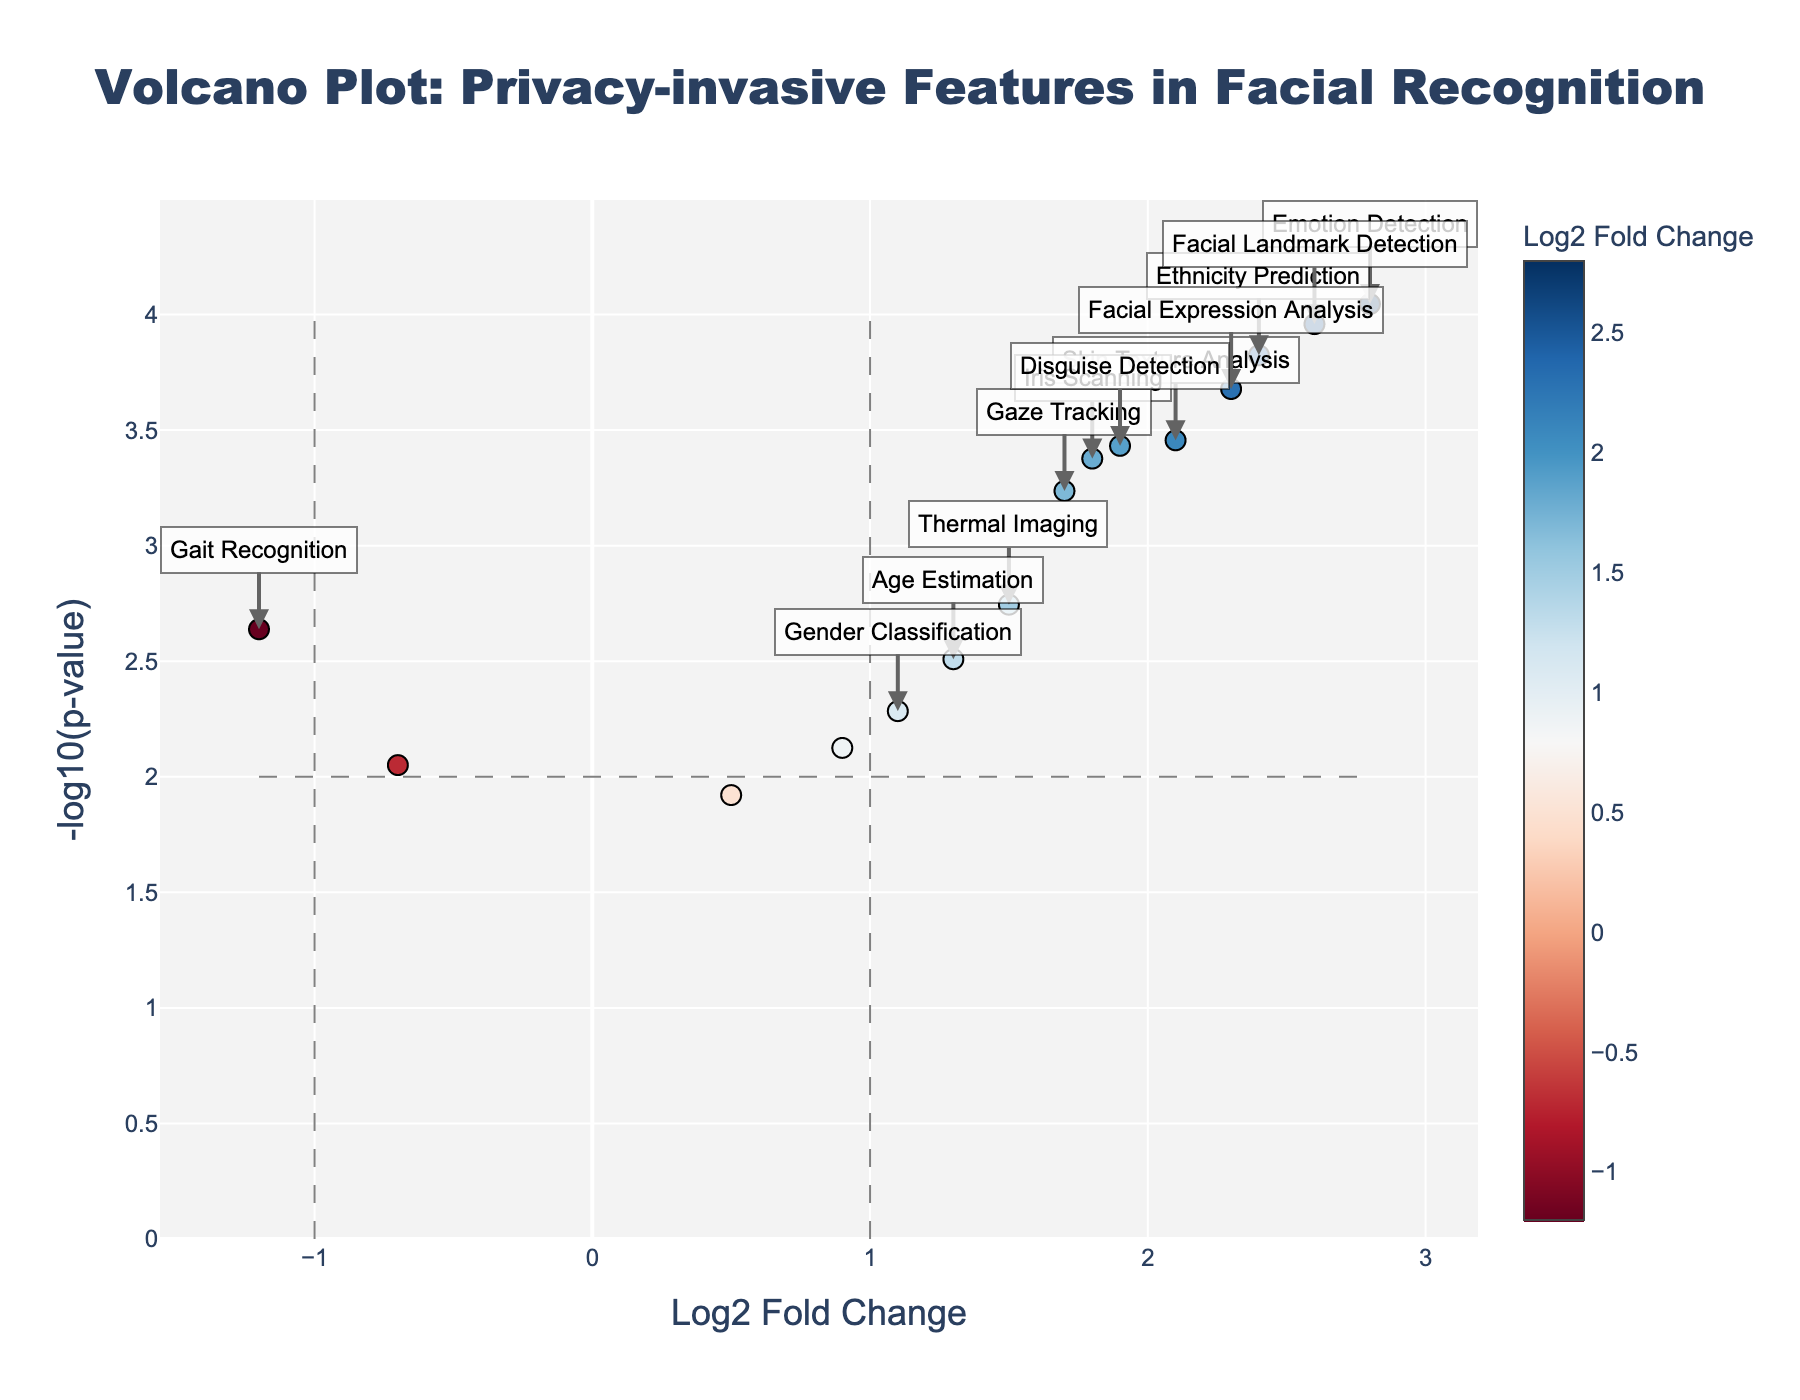How many features are plotted in the Volcano Plot? Count each data point representing a feature in the plot. There are 15 points, each corresponding to a unique feature.
Answer: 15 Which feature shows the highest fold change in privacy-invasive methods? Look for the data point farthest to the right on the X-axis (log2 Fold Change). "Emotion Detection" has the highest log2 fold change at 2.8.
Answer: Emotion Detection What is the significance threshold for the p-value indicated by the horizontal dashed line? Identify the -log10(p-value) for the horizontal line. The p-value threshold is 0.01, which corresponds to -log10(0.01) = 2.
Answer: 2 What feature is the least significant according to the plot, and what are its log2 fold change and p-value? Find the feature with the smallest -log10(p-value). "Tattoo Recognition" has the lowest significance with -log10(p-value) around 1.92, and its log2 fold change is 0.5.
Answer: Tattoo Recognition, log2 Fold Change: 0.5, p-value: 0.012 Which feature is most associated with a decrease in privacy invasion compared to traditional methods? Look for the data point farthest to the left with a negative log2 fold change. "Gait Recognition" has the lowest log2 fold change at -1.2.
Answer: Gait Recognition Compare the p-values of "Gaze Tracking" and "Skin Texture Analysis." Which is lower, and how do you know? Find the dots associated with each feature and compare their y-axis positions (-log10(p-value)). "Skin Texture Analysis" is higher up the y-axis, hence it has a lower p-value.
Answer: Skin Texture Analysis has a lower p-value How many features have a log2 fold change greater than 2? Count the points to the right of the vertical line marking log2 fold change = 2. There are 4 features: "Emotion Detection", "Skin Texture Analysis", "Facial Landmark Detection", and "Facial Expression Analysis".
Answer: 4 What does the color of the markers represent on this plot? The color gradient from blue to red represents the log2 fold change values. The color bar indicates this by showing how colors change with different log2 fold change values.
Answer: Log2 fold change 